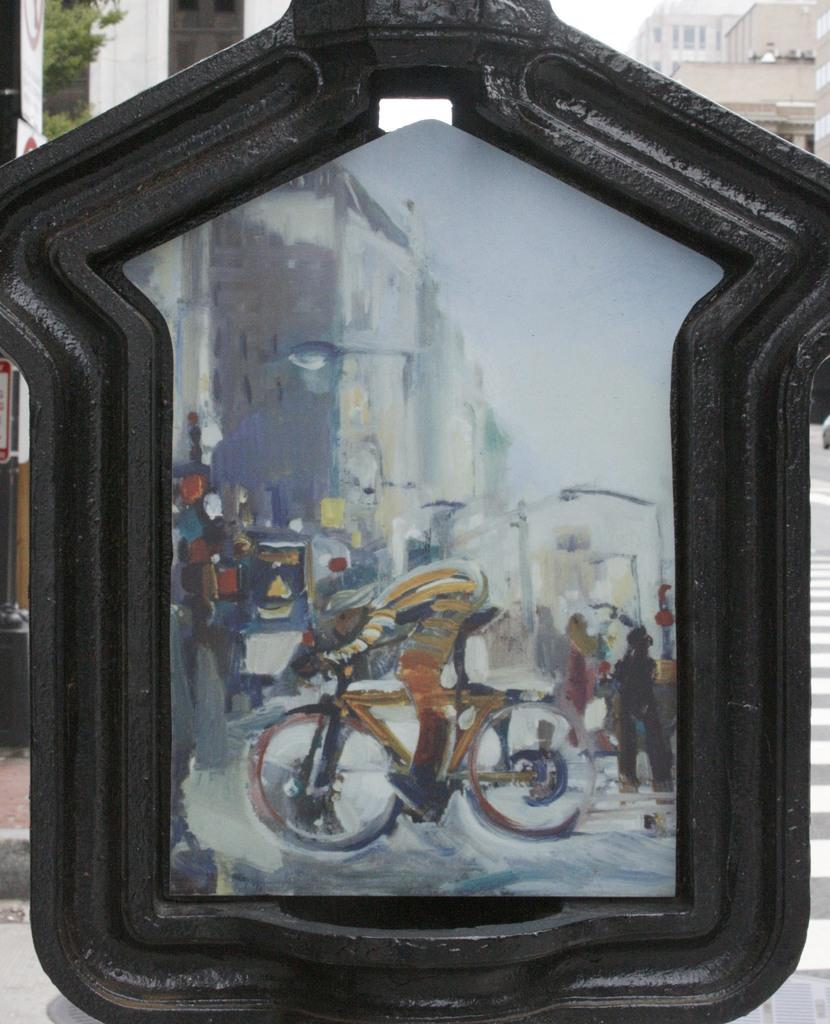What is depicted on the board in the image? There is a painting on a board in the image. What can be seen in the distance behind the board? There are buildings in the background of the image. What part of the natural environment is visible in the image? The sky is visible in the background of the image. What type of bell can be heard ringing in the image? There is no bell present in the image, and therefore no sound can be heard. 